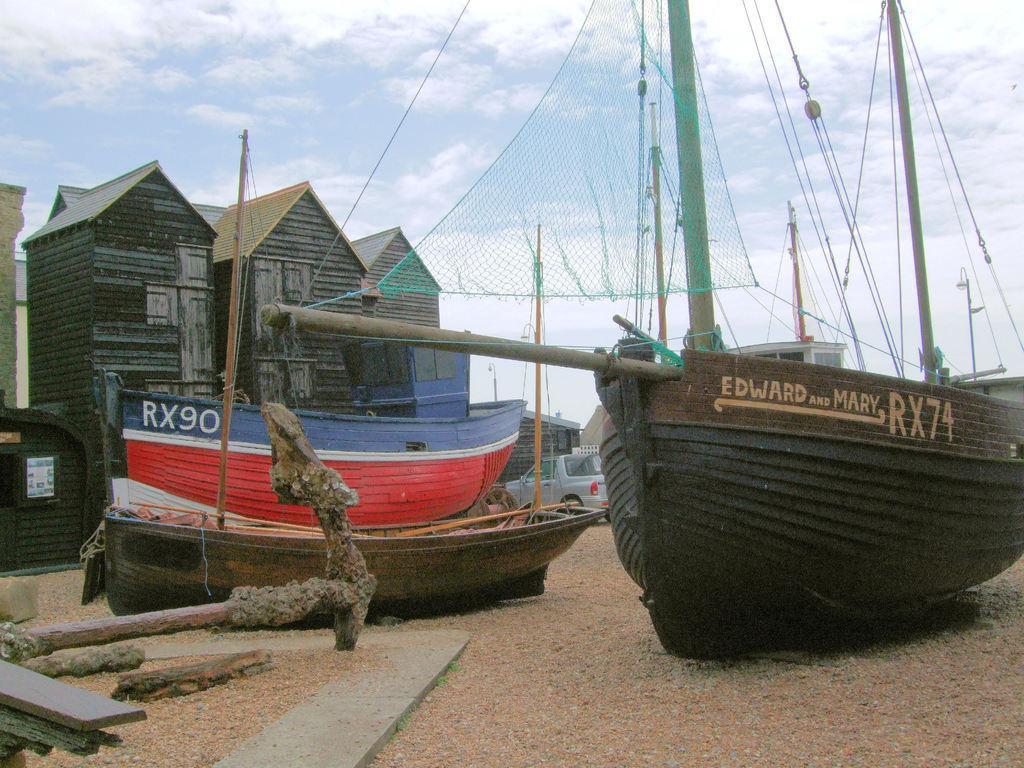Please provide a concise description of this image. In this picture we can see boats in the front, at the bottom there are some stones, on the left side we can see buildings, there is a vehicle in the middle, we can see the sky and clouds at the top of the picture. 